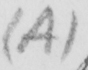Can you tell me what this handwritten text says? ( A ) 